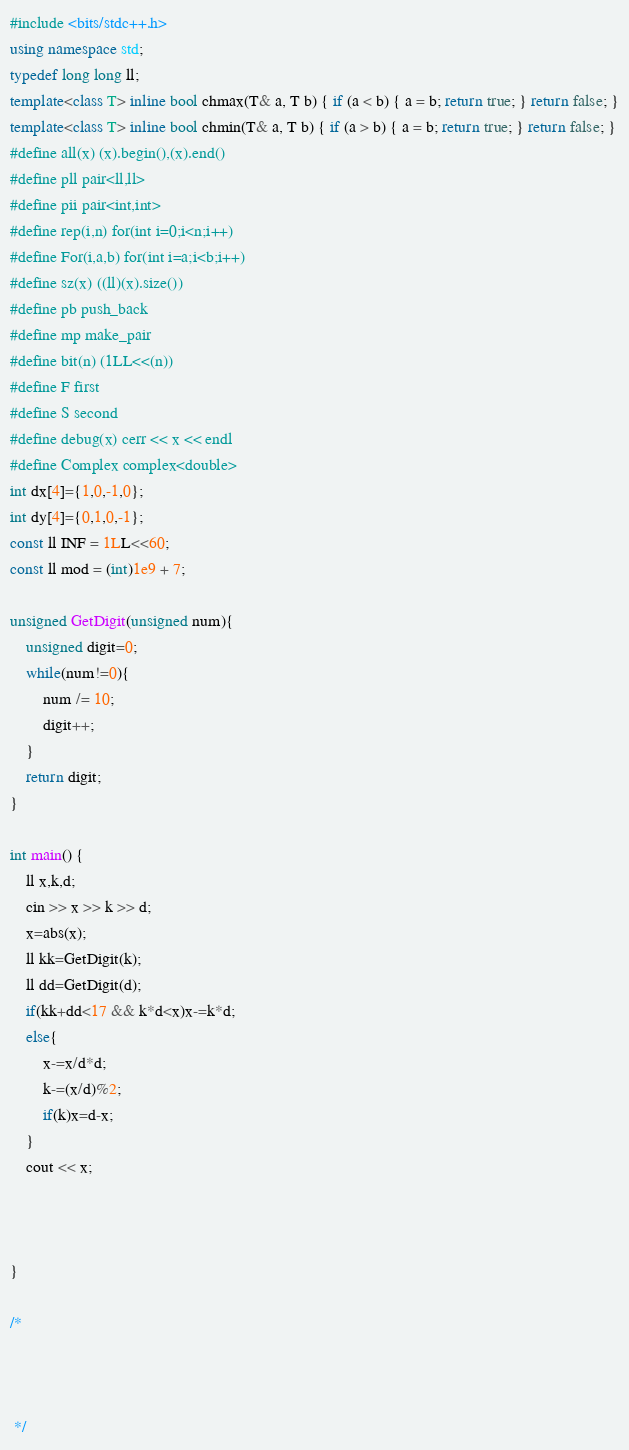<code> <loc_0><loc_0><loc_500><loc_500><_C++_>#include <bits/stdc++.h>
using namespace std;
typedef long long ll;
template<class T> inline bool chmax(T& a, T b) { if (a < b) { a = b; return true; } return false; }
template<class T> inline bool chmin(T& a, T b) { if (a > b) { a = b; return true; } return false; }
#define all(x) (x).begin(),(x).end()
#define pll pair<ll,ll>
#define pii pair<int,int>
#define rep(i,n) for(int i=0;i<n;i++)
#define For(i,a,b) for(int i=a;i<b;i++)
#define sz(x) ((ll)(x).size())
#define pb push_back
#define mp make_pair
#define bit(n) (1LL<<(n))
#define F first
#define S second
#define debug(x) cerr << x << endl
#define Complex complex<double>
int dx[4]={1,0,-1,0};
int dy[4]={0,1,0,-1};
const ll INF = 1LL<<60;
const ll mod = (int)1e9 + 7;

unsigned GetDigit(unsigned num){
    unsigned digit=0;
    while(num!=0){
        num /= 10;
        digit++;
    }
    return digit;
}

int main() {
    ll x,k,d;
    cin >> x >> k >> d;
    x=abs(x);
    ll kk=GetDigit(k);
    ll dd=GetDigit(d);
    if(kk+dd<17 && k*d<x)x-=k*d;
    else{
        x-=x/d*d;
        k-=(x/d)%2;
        if(k)x=d-x;
    }
    cout << x;
    


}

/*



 */
</code> 